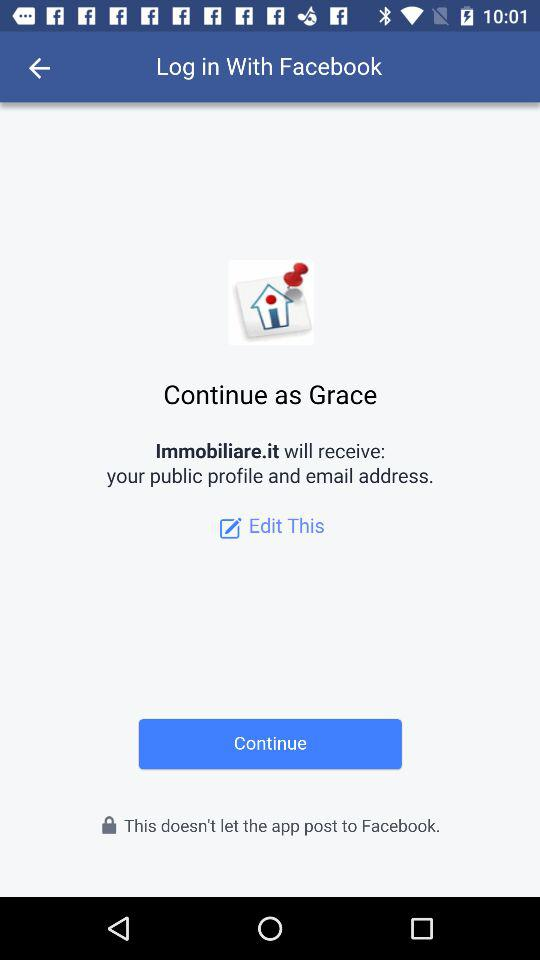What application will receive the public profile and email address? The public profile and email address will be received by "Immobiliare.it". 